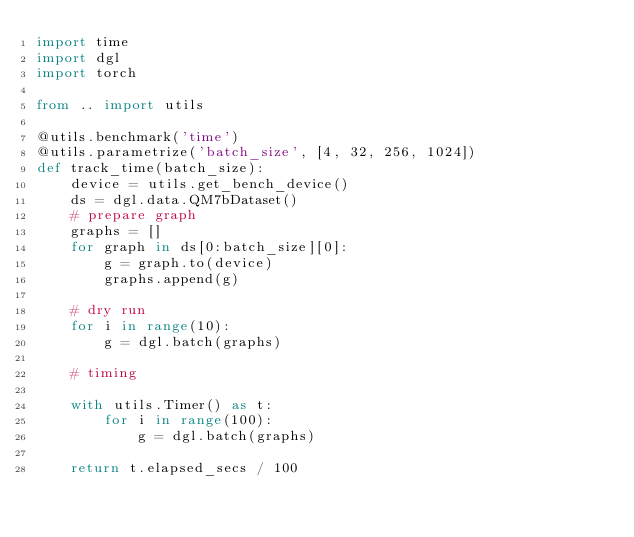Convert code to text. <code><loc_0><loc_0><loc_500><loc_500><_Python_>import time
import dgl
import torch

from .. import utils

@utils.benchmark('time')
@utils.parametrize('batch_size', [4, 32, 256, 1024])
def track_time(batch_size):
    device = utils.get_bench_device()
    ds = dgl.data.QM7bDataset()
    # prepare graph
    graphs = []
    for graph in ds[0:batch_size][0]:
        g = graph.to(device)
        graphs.append(g)

    # dry run
    for i in range(10):
        g = dgl.batch(graphs)

    # timing
    
    with utils.Timer() as t:
        for i in range(100):
            g = dgl.batch(graphs)

    return t.elapsed_secs / 100
</code> 